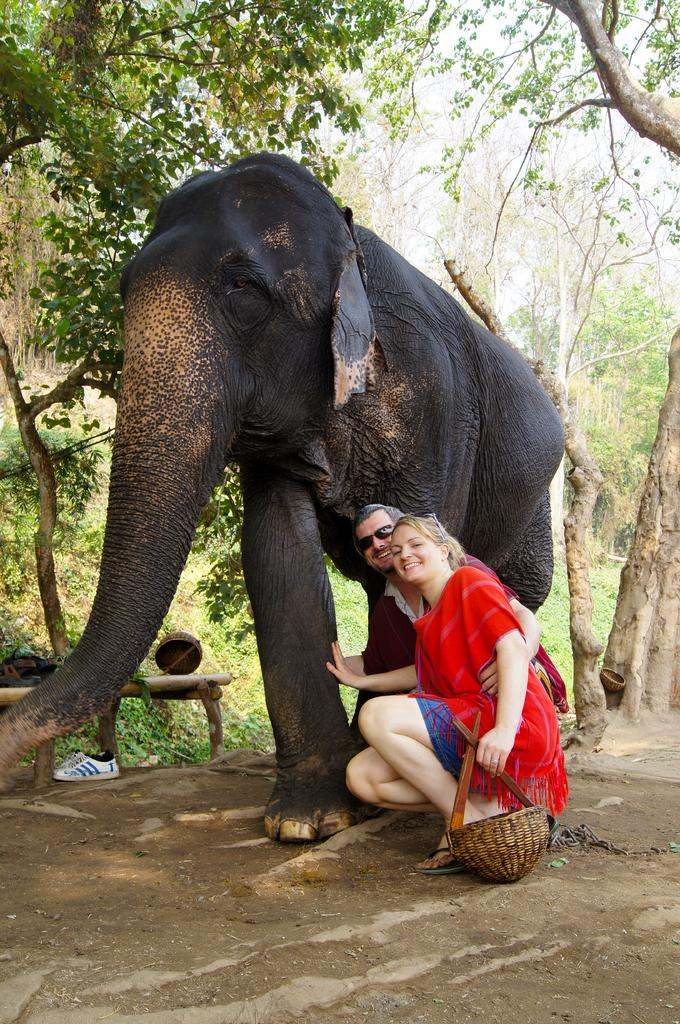What is the main subject of the picture? The main subject of the picture is an elephant. What are the two persons doing in the picture? The two persons are sitting down on the elephant. What is the expression on the faces of the persons? The persons are smiling. What can be seen in the background of the picture? There are trees and the sky visible in the background of the picture. How much does the baby cost in the image? There is no baby present in the image, and therefore no price associated with it. 